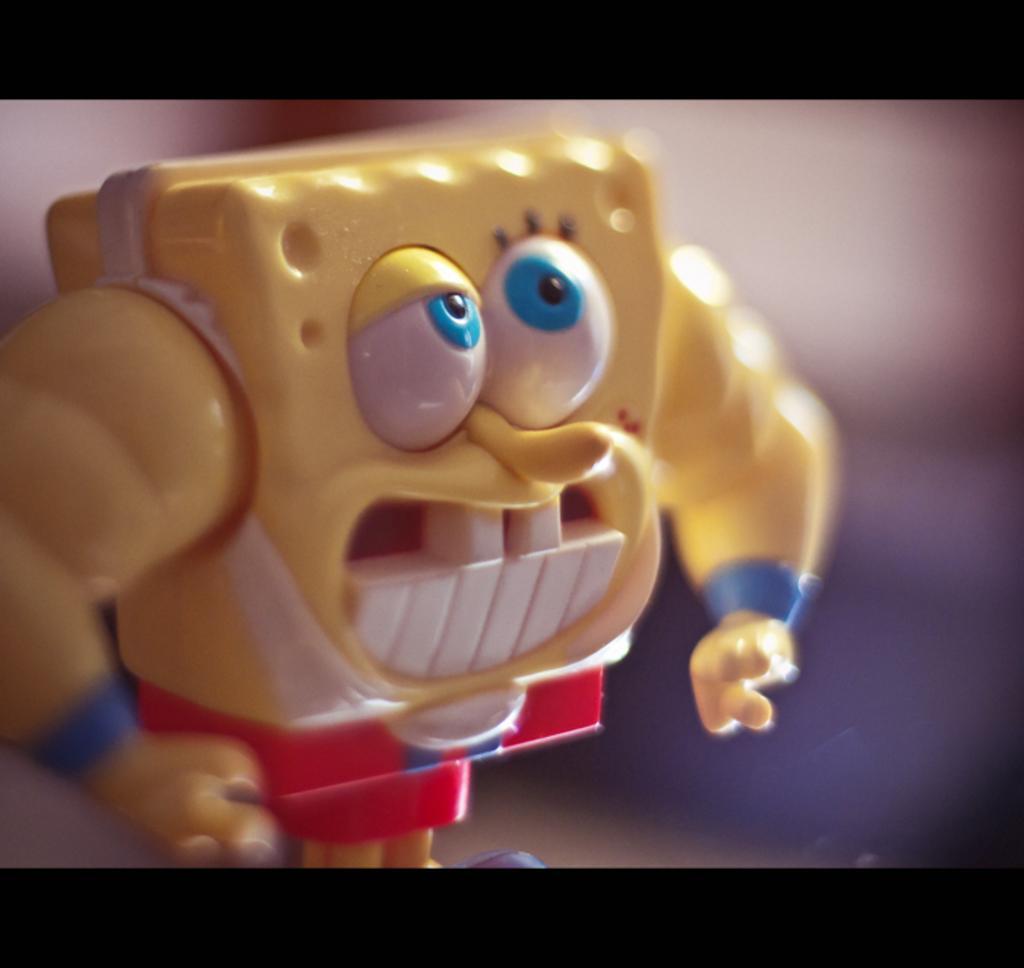In one or two sentences, can you explain what this image depicts? In this image, we can see a toy. 